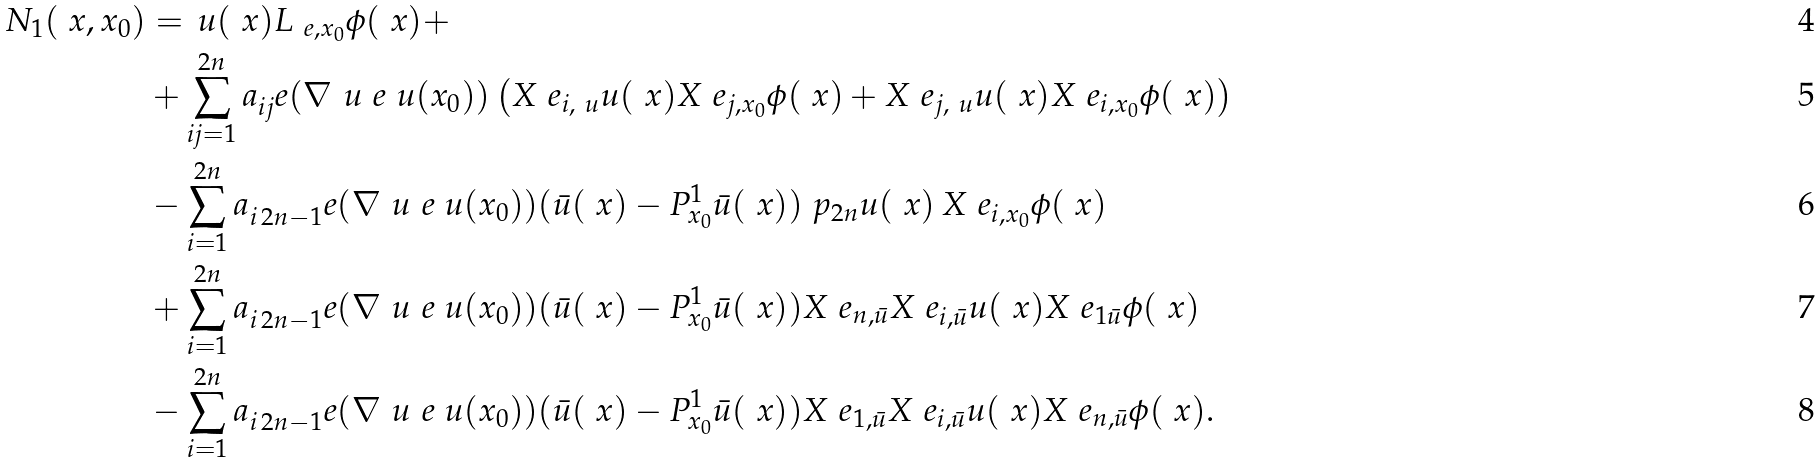Convert formula to latex. <formula><loc_0><loc_0><loc_500><loc_500>N _ { 1 } ( \ x , x _ { 0 } ) & = \, u ( \ x ) L _ { \ e , x _ { 0 } } \phi ( \ x ) + \\ & + \sum _ { i j = 1 } ^ { 2 n } a _ { i j } ^ { \ } e ( \nabla _ { \ } u ^ { \ } e \ u ( x _ { 0 } ) ) \left ( X ^ { \ } e _ { i , \ u } u ( \ x ) X ^ { \ } e _ { j , x _ { 0 } } \phi ( \ x ) + X ^ { \ } e _ { j , \ u } u ( \ x ) X ^ { \ } e _ { i , x _ { 0 } } \phi ( \ x ) \right ) \\ & - \sum _ { i = 1 } ^ { 2 n } a _ { i \, 2 n - 1 } ^ { \ } e ( \nabla _ { \ } u ^ { \ } e \ u ( x _ { 0 } ) ) ( \bar { u } ( \ x ) - P ^ { 1 } _ { x _ { 0 } } \bar { u } ( \ x ) ) \ p _ { 2 n } u ( \ x ) \, X ^ { \ } e _ { i , x _ { 0 } } \phi ( \ x ) \\ & + \sum _ { i = 1 } ^ { 2 n } a _ { i \, 2 n - 1 } ^ { \ } e ( \nabla _ { \ } u ^ { \ } e \ u ( x _ { 0 } ) ) ( \bar { u } ( \ x ) - P ^ { 1 } _ { x _ { 0 } } \bar { u } ( \ x ) ) X ^ { \ } e _ { n , \bar { u } } X ^ { \ } e _ { i , \bar { u } } u ( \ x ) X ^ { \ } e _ { 1 \bar { u } } \phi ( \ x ) \\ & - \sum _ { i = 1 } ^ { 2 n } a _ { i \, 2 n - 1 } ^ { \ } e ( \nabla _ { \ } u ^ { \ } e \ u ( x _ { 0 } ) ) ( \bar { u } ( \ x ) - P ^ { 1 } _ { x _ { 0 } } \bar { u } ( \ x ) ) X ^ { \ } e _ { 1 , \bar { u } } X ^ { \ } e _ { i , \bar { u } } u ( \ x ) X ^ { \ } e _ { n , \bar { u } } \phi ( \ x ) .</formula> 